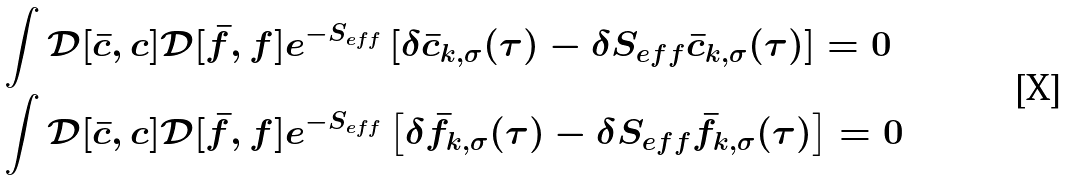<formula> <loc_0><loc_0><loc_500><loc_500>& \int \mathcal { D } [ \bar { c } , c ] \mathcal { D } [ \bar { f } , f ] e ^ { - S _ { e f f } } \left [ \delta \bar { c } _ { k , \sigma } ( \tau ) - \delta S _ { e f f } \bar { c } _ { k , \sigma } ( \tau ) \right ] = 0 \\ & \int \mathcal { D } [ \bar { c } , c ] \mathcal { D } [ \bar { f } , f ] e ^ { - S _ { e f f } } \left [ \delta \bar { f } _ { k , \sigma } ( \tau ) - \delta S _ { e f f } \bar { f } _ { k , \sigma } ( \tau ) \right ] = 0</formula> 